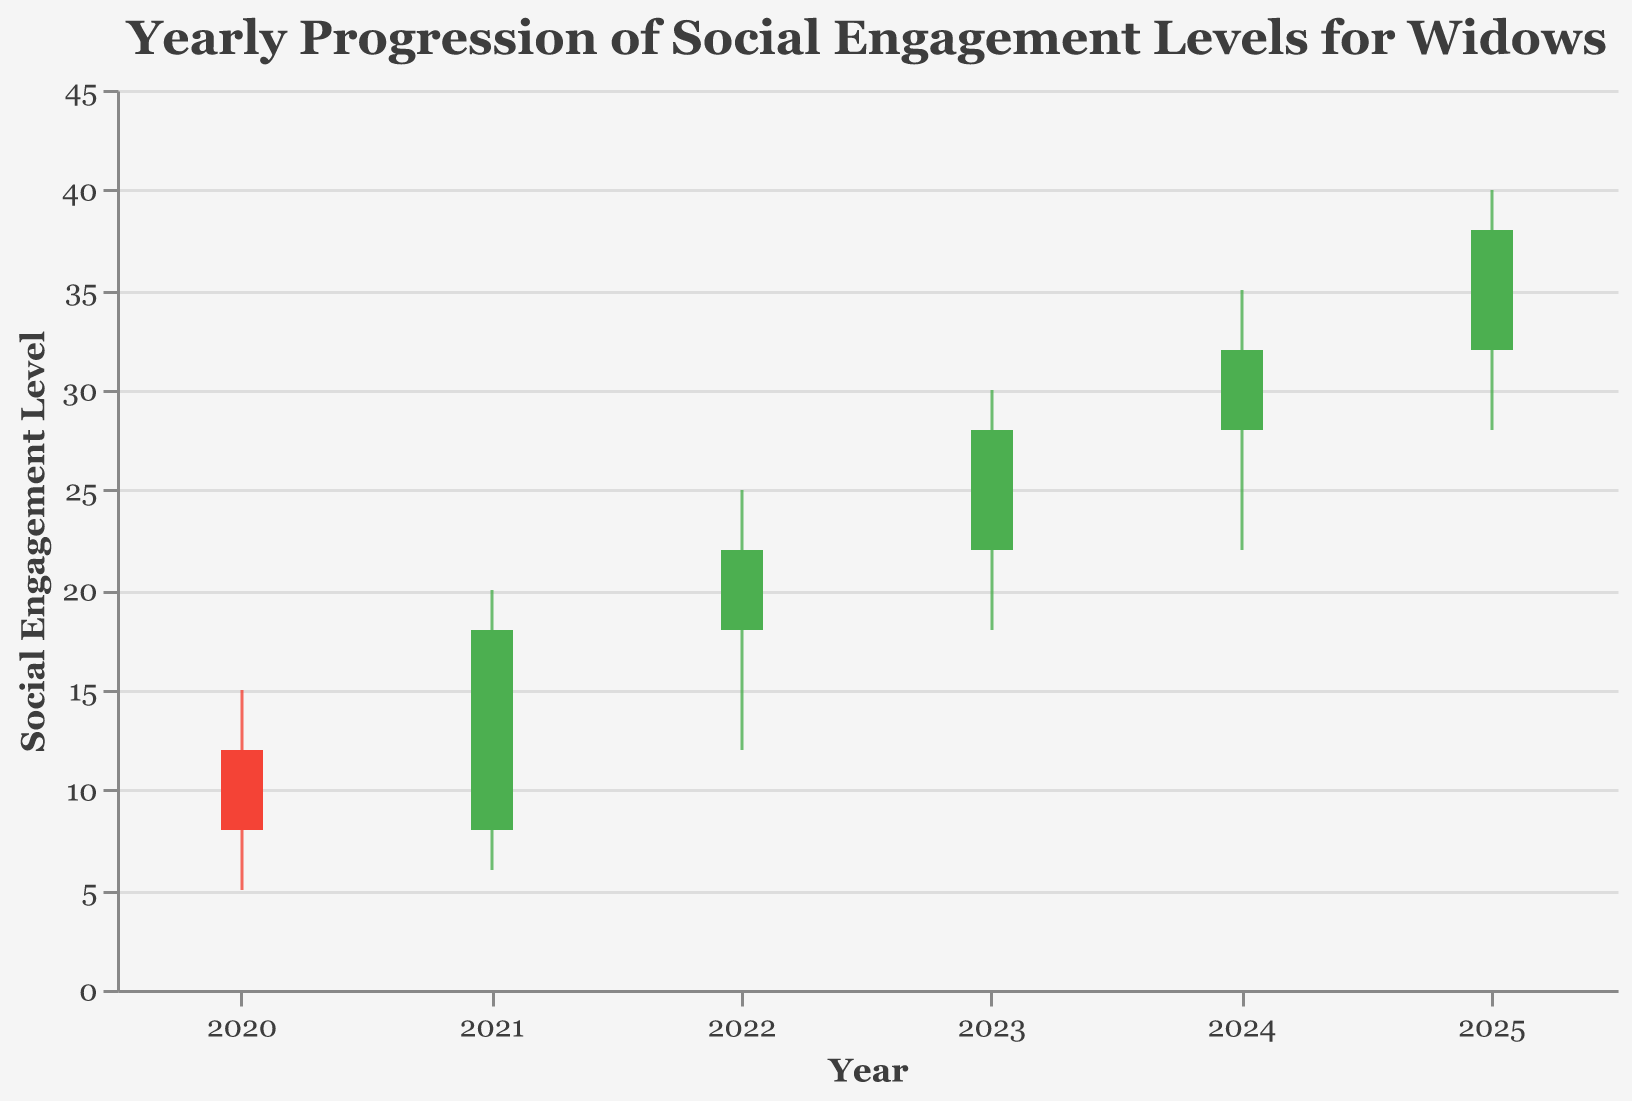What is the title of the chart? The title is often displayed at the top of the chart and provides a summary of what the chart represents. Here, it reads "Yearly Progression of Social Engagement Levels for Widows".
Answer: Yearly Progression of Social Engagement Levels for Widows How many years of data are shown in the chart? By counting the distinct years on the x-axis, we can see the years listed from 2020 to 2025, making it a total of six years.
Answer: 6 What color represents an increase in social engagement? The color green is used to symbolize an increase in social engagement level where the closing value is higher than the opening value.
Answer: Green In which year was the highest level of social engagement recorded? By looking at the highest value reached on the y-axis for each year, we can see that the highest level (40) was recorded in 2025.
Answer: 2025 What is the range of social engagement levels in 2021? The range is determined by the difference between the high and low values for 2021. The high is 20 and the low is 6, so the range is 20 - 6 = 14.
Answer: 14 Did the social engagement level increase or decrease from 2020 to 2021? We can determine this by comparing the close value of 2020 (8) with the open value of 2021 (8). Since they are equal, there was no increase or decrease in the levels.
Answer: Stayed the same What was the lowest social engagement level reached in 2023? The lowest level can be found in the "Low" value for 2023, which is 18.
Answer: 18 Which year had the largest increase in social engagement levels? By comparing the difference between the open and close values for each year, we can see that 2025 had the largest increase (38 - 32 = 6).
Answer: 2025 Is there any year where the social engagement level decreased from the opening to the closing value? Looking at the color of the bars, red indicates a decrease. The year 2020 has a red bar, indicating the level decreased from 12 (open) to 8 (close).
Answer: 2020 What is the average closing value over the years? To find the average, sum up the closing values (8 + 18 + 22 + 28 + 32 + 38 = 146) and divide by the number of years (6), which yields 146/6 ≈ 24.33.
Answer: 24.33 